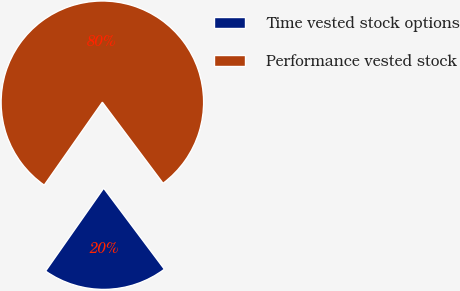Convert chart to OTSL. <chart><loc_0><loc_0><loc_500><loc_500><pie_chart><fcel>Time vested stock options<fcel>Performance vested stock<nl><fcel>19.96%<fcel>80.04%<nl></chart> 